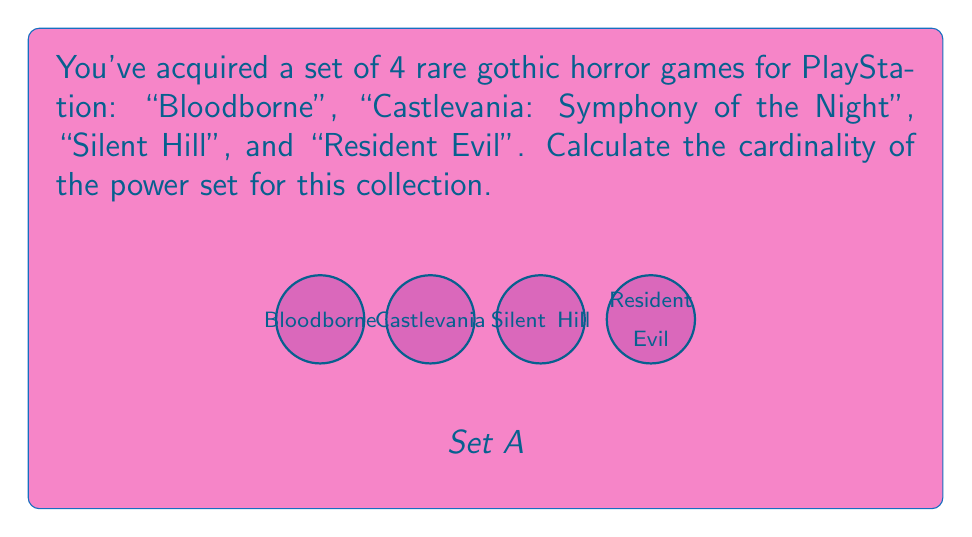Can you solve this math problem? Let's approach this step-by-step:

1) First, recall that the power set of a set A is the set of all subsets of A, including the empty set and A itself.

2) The formula for the cardinality of a power set is:

   $$|P(A)| = 2^n$$

   where n is the number of elements in the original set A.

3) In this case, we have 4 games in our set:
   A = {Bloodborne, Castlevania: Symphony of the Night, Silent Hill, Resident Evil}

4) Therefore, n = 4

5) Applying the formula:

   $$|P(A)| = 2^4 = 16$$

6) We can verify this by listing all possible subsets:
   - Empty set: {}
   - 4 single-element sets: {Bloodborne}, {Castlevania}, {Silent Hill}, {Resident Evil}
   - 6 two-element sets: {Bloodborne, Castlevania}, {Bloodborne, Silent Hill}, {Bloodborne, Resident Evil}, {Castlevania, Silent Hill}, {Castlevania, Resident Evil}, {Silent Hill, Resident Evil}
   - 4 three-element sets: {Bloodborne, Castlevania, Silent Hill}, {Bloodborne, Castlevania, Resident Evil}, {Bloodborne, Silent Hill, Resident Evil}, {Castlevania, Silent Hill, Resident Evil}
   - 1 four-element set: {Bloodborne, Castlevania, Silent Hill, Resident Evil}

   Indeed, 1 + 4 + 6 + 4 + 1 = 16
Answer: 16 